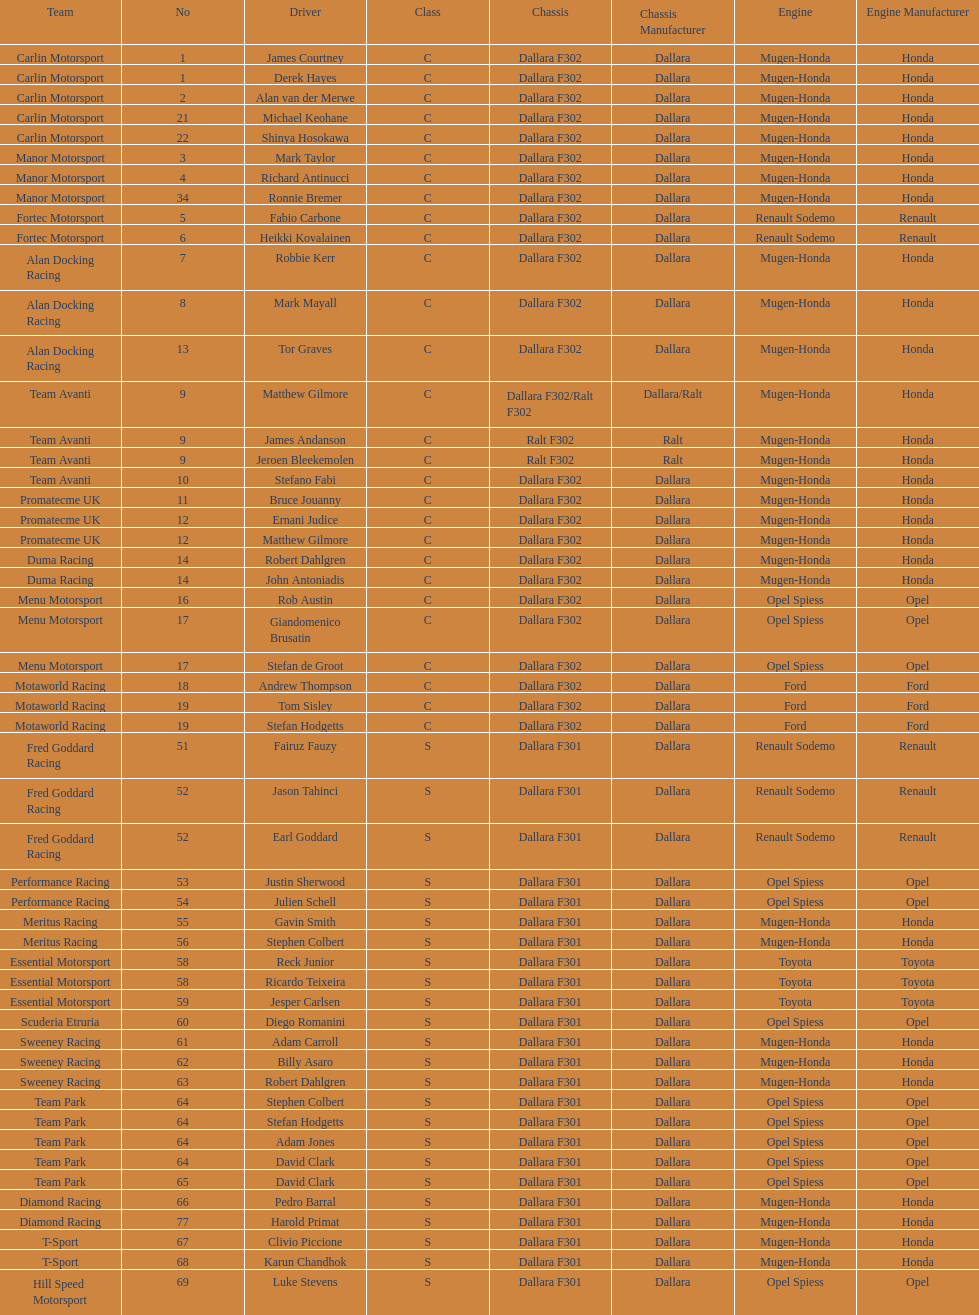Which engine was used the most by teams this season? Mugen-Honda. Could you parse the entire table as a dict? {'header': ['Team', 'No', 'Driver', 'Class', 'Chassis', 'Chassis Manufacturer', 'Engine', 'Engine Manufacturer'], 'rows': [['Carlin Motorsport', '1', 'James Courtney', 'C', 'Dallara F302', 'Dallara', 'Mugen-Honda', 'Honda'], ['Carlin Motorsport', '1', 'Derek Hayes', 'C', 'Dallara F302', 'Dallara', 'Mugen-Honda', 'Honda'], ['Carlin Motorsport', '2', 'Alan van der Merwe', 'C', 'Dallara F302', 'Dallara', 'Mugen-Honda', 'Honda'], ['Carlin Motorsport', '21', 'Michael Keohane', 'C', 'Dallara F302', 'Dallara', 'Mugen-Honda', 'Honda'], ['Carlin Motorsport', '22', 'Shinya Hosokawa', 'C', 'Dallara F302', 'Dallara', 'Mugen-Honda', 'Honda'], ['Manor Motorsport', '3', 'Mark Taylor', 'C', 'Dallara F302', 'Dallara', 'Mugen-Honda', 'Honda'], ['Manor Motorsport', '4', 'Richard Antinucci', 'C', 'Dallara F302', 'Dallara', 'Mugen-Honda', 'Honda'], ['Manor Motorsport', '34', 'Ronnie Bremer', 'C', 'Dallara F302', 'Dallara', 'Mugen-Honda', 'Honda'], ['Fortec Motorsport', '5', 'Fabio Carbone', 'C', 'Dallara F302', 'Dallara', 'Renault Sodemo', 'Renault'], ['Fortec Motorsport', '6', 'Heikki Kovalainen', 'C', 'Dallara F302', 'Dallara', 'Renault Sodemo', 'Renault'], ['Alan Docking Racing', '7', 'Robbie Kerr', 'C', 'Dallara F302', 'Dallara', 'Mugen-Honda', 'Honda'], ['Alan Docking Racing', '8', 'Mark Mayall', 'C', 'Dallara F302', 'Dallara', 'Mugen-Honda', 'Honda'], ['Alan Docking Racing', '13', 'Tor Graves', 'C', 'Dallara F302', 'Dallara', 'Mugen-Honda', 'Honda'], ['Team Avanti', '9', 'Matthew Gilmore', 'C', 'Dallara F302/Ralt F302', 'Dallara/Ralt', 'Mugen-Honda', 'Honda'], ['Team Avanti', '9', 'James Andanson', 'C', 'Ralt F302', 'Ralt', 'Mugen-Honda', 'Honda'], ['Team Avanti', '9', 'Jeroen Bleekemolen', 'C', 'Ralt F302', 'Ralt', 'Mugen-Honda', 'Honda'], ['Team Avanti', '10', 'Stefano Fabi', 'C', 'Dallara F302', 'Dallara', 'Mugen-Honda', 'Honda'], ['Promatecme UK', '11', 'Bruce Jouanny', 'C', 'Dallara F302', 'Dallara', 'Mugen-Honda', 'Honda'], ['Promatecme UK', '12', 'Ernani Judice', 'C', 'Dallara F302', 'Dallara', 'Mugen-Honda', 'Honda'], ['Promatecme UK', '12', 'Matthew Gilmore', 'C', 'Dallara F302', 'Dallara', 'Mugen-Honda', 'Honda'], ['Duma Racing', '14', 'Robert Dahlgren', 'C', 'Dallara F302', 'Dallara', 'Mugen-Honda', 'Honda'], ['Duma Racing', '14', 'John Antoniadis', 'C', 'Dallara F302', 'Dallara', 'Mugen-Honda', 'Honda'], ['Menu Motorsport', '16', 'Rob Austin', 'C', 'Dallara F302', 'Dallara', 'Opel Spiess', 'Opel'], ['Menu Motorsport', '17', 'Giandomenico Brusatin', 'C', 'Dallara F302', 'Dallara', 'Opel Spiess', 'Opel'], ['Menu Motorsport', '17', 'Stefan de Groot', 'C', 'Dallara F302', 'Dallara', 'Opel Spiess', 'Opel'], ['Motaworld Racing', '18', 'Andrew Thompson', 'C', 'Dallara F302', 'Dallara', 'Ford', 'Ford'], ['Motaworld Racing', '19', 'Tom Sisley', 'C', 'Dallara F302', 'Dallara', 'Ford', 'Ford'], ['Motaworld Racing', '19', 'Stefan Hodgetts', 'C', 'Dallara F302', 'Dallara', 'Ford', 'Ford'], ['Fred Goddard Racing', '51', 'Fairuz Fauzy', 'S', 'Dallara F301', 'Dallara', 'Renault Sodemo', 'Renault'], ['Fred Goddard Racing', '52', 'Jason Tahinci', 'S', 'Dallara F301', 'Dallara', 'Renault Sodemo', 'Renault'], ['Fred Goddard Racing', '52', 'Earl Goddard', 'S', 'Dallara F301', 'Dallara', 'Renault Sodemo', 'Renault'], ['Performance Racing', '53', 'Justin Sherwood', 'S', 'Dallara F301', 'Dallara', 'Opel Spiess', 'Opel'], ['Performance Racing', '54', 'Julien Schell', 'S', 'Dallara F301', 'Dallara', 'Opel Spiess', 'Opel'], ['Meritus Racing', '55', 'Gavin Smith', 'S', 'Dallara F301', 'Dallara', 'Mugen-Honda', 'Honda'], ['Meritus Racing', '56', 'Stephen Colbert', 'S', 'Dallara F301', 'Dallara', 'Mugen-Honda', 'Honda'], ['Essential Motorsport', '58', 'Reck Junior', 'S', 'Dallara F301', 'Dallara', 'Toyota', 'Toyota'], ['Essential Motorsport', '58', 'Ricardo Teixeira', 'S', 'Dallara F301', 'Dallara', 'Toyota', 'Toyota'], ['Essential Motorsport', '59', 'Jesper Carlsen', 'S', 'Dallara F301', 'Dallara', 'Toyota', 'Toyota'], ['Scuderia Etruria', '60', 'Diego Romanini', 'S', 'Dallara F301', 'Dallara', 'Opel Spiess', 'Opel'], ['Sweeney Racing', '61', 'Adam Carroll', 'S', 'Dallara F301', 'Dallara', 'Mugen-Honda', 'Honda'], ['Sweeney Racing', '62', 'Billy Asaro', 'S', 'Dallara F301', 'Dallara', 'Mugen-Honda', 'Honda'], ['Sweeney Racing', '63', 'Robert Dahlgren', 'S', 'Dallara F301', 'Dallara', 'Mugen-Honda', 'Honda'], ['Team Park', '64', 'Stephen Colbert', 'S', 'Dallara F301', 'Dallara', 'Opel Spiess', 'Opel'], ['Team Park', '64', 'Stefan Hodgetts', 'S', 'Dallara F301', 'Dallara', 'Opel Spiess', 'Opel'], ['Team Park', '64', 'Adam Jones', 'S', 'Dallara F301', 'Dallara', 'Opel Spiess', 'Opel'], ['Team Park', '64', 'David Clark', 'S', 'Dallara F301', 'Dallara', 'Opel Spiess', 'Opel'], ['Team Park', '65', 'David Clark', 'S', 'Dallara F301', 'Dallara', 'Opel Spiess', 'Opel'], ['Diamond Racing', '66', 'Pedro Barral', 'S', 'Dallara F301', 'Dallara', 'Mugen-Honda', 'Honda'], ['Diamond Racing', '77', 'Harold Primat', 'S', 'Dallara F301', 'Dallara', 'Mugen-Honda', 'Honda'], ['T-Sport', '67', 'Clivio Piccione', 'S', 'Dallara F301', 'Dallara', 'Mugen-Honda', 'Honda'], ['T-Sport', '68', 'Karun Chandhok', 'S', 'Dallara F301', 'Dallara', 'Mugen-Honda', 'Honda'], ['Hill Speed Motorsport', '69', 'Luke Stevens', 'S', 'Dallara F301', 'Dallara', 'Opel Spiess', 'Opel']]} 